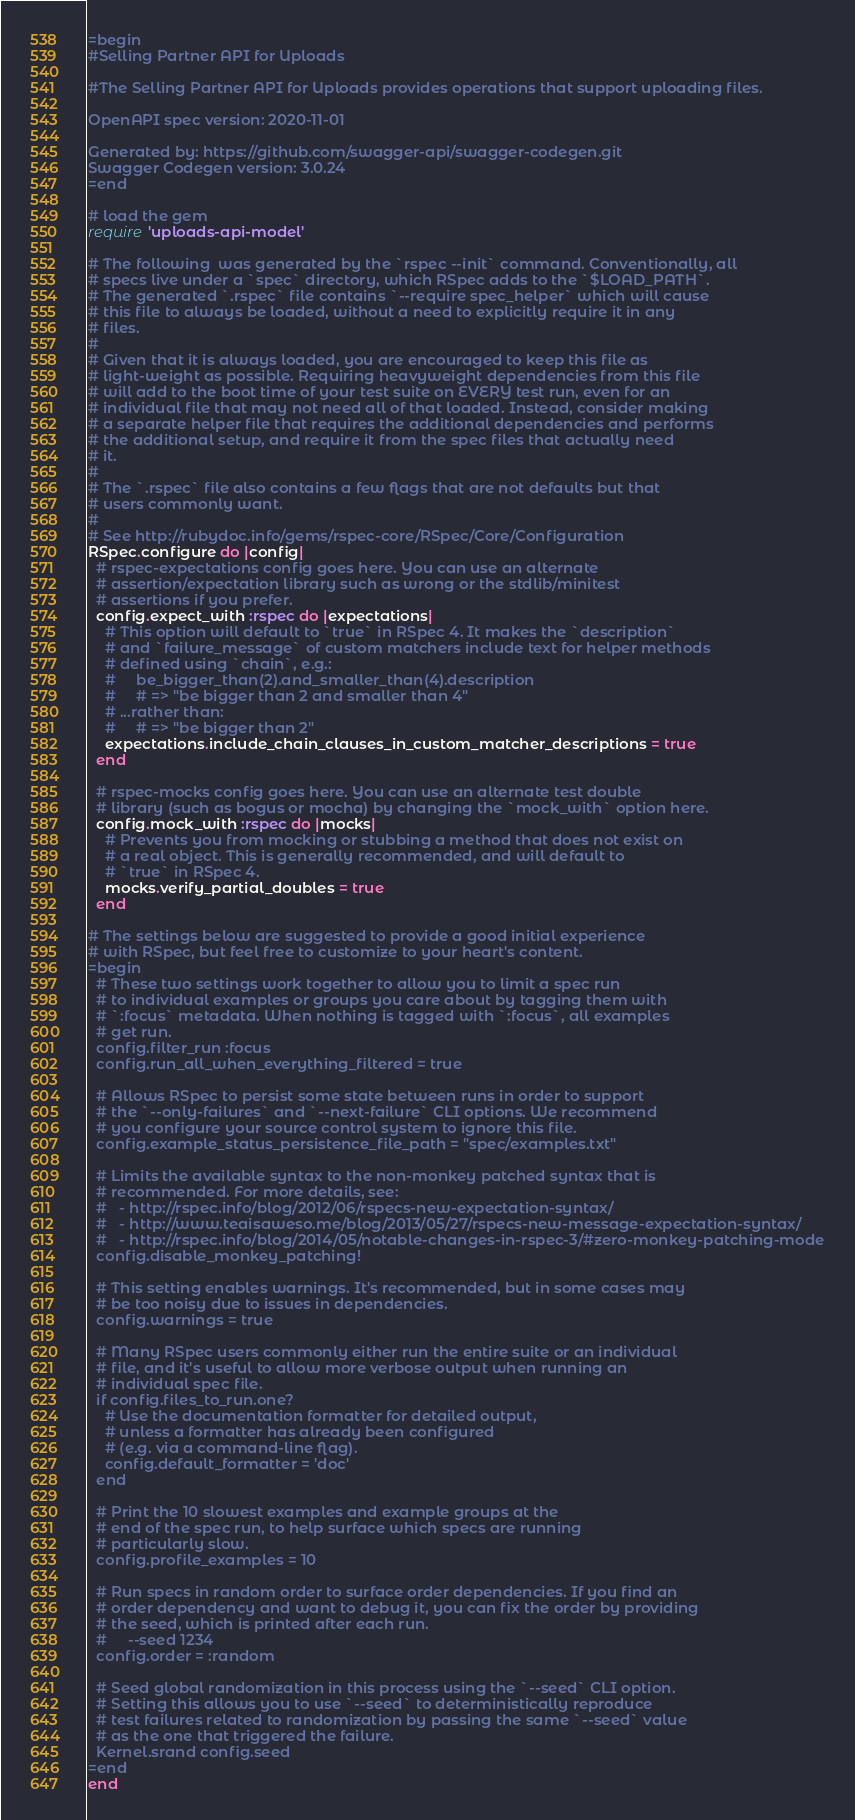<code> <loc_0><loc_0><loc_500><loc_500><_Ruby_>=begin
#Selling Partner API for Uploads

#The Selling Partner API for Uploads provides operations that support uploading files.

OpenAPI spec version: 2020-11-01

Generated by: https://github.com/swagger-api/swagger-codegen.git
Swagger Codegen version: 3.0.24
=end

# load the gem
require 'uploads-api-model'

# The following  was generated by the `rspec --init` command. Conventionally, all
# specs live under a `spec` directory, which RSpec adds to the `$LOAD_PATH`.
# The generated `.rspec` file contains `--require spec_helper` which will cause
# this file to always be loaded, without a need to explicitly require it in any
# files.
#
# Given that it is always loaded, you are encouraged to keep this file as
# light-weight as possible. Requiring heavyweight dependencies from this file
# will add to the boot time of your test suite on EVERY test run, even for an
# individual file that may not need all of that loaded. Instead, consider making
# a separate helper file that requires the additional dependencies and performs
# the additional setup, and require it from the spec files that actually need
# it.
#
# The `.rspec` file also contains a few flags that are not defaults but that
# users commonly want.
#
# See http://rubydoc.info/gems/rspec-core/RSpec/Core/Configuration
RSpec.configure do |config|
  # rspec-expectations config goes here. You can use an alternate
  # assertion/expectation library such as wrong or the stdlib/minitest
  # assertions if you prefer.
  config.expect_with :rspec do |expectations|
    # This option will default to `true` in RSpec 4. It makes the `description`
    # and `failure_message` of custom matchers include text for helper methods
    # defined using `chain`, e.g.:
    #     be_bigger_than(2).and_smaller_than(4).description
    #     # => "be bigger than 2 and smaller than 4"
    # ...rather than:
    #     # => "be bigger than 2"
    expectations.include_chain_clauses_in_custom_matcher_descriptions = true
  end

  # rspec-mocks config goes here. You can use an alternate test double
  # library (such as bogus or mocha) by changing the `mock_with` option here.
  config.mock_with :rspec do |mocks|
    # Prevents you from mocking or stubbing a method that does not exist on
    # a real object. This is generally recommended, and will default to
    # `true` in RSpec 4.
    mocks.verify_partial_doubles = true
  end

# The settings below are suggested to provide a good initial experience
# with RSpec, but feel free to customize to your heart's content.
=begin
  # These two settings work together to allow you to limit a spec run
  # to individual examples or groups you care about by tagging them with
  # `:focus` metadata. When nothing is tagged with `:focus`, all examples
  # get run.
  config.filter_run :focus
  config.run_all_when_everything_filtered = true

  # Allows RSpec to persist some state between runs in order to support
  # the `--only-failures` and `--next-failure` CLI options. We recommend
  # you configure your source control system to ignore this file.
  config.example_status_persistence_file_path = "spec/examples.txt"

  # Limits the available syntax to the non-monkey patched syntax that is
  # recommended. For more details, see:
  #   - http://rspec.info/blog/2012/06/rspecs-new-expectation-syntax/
  #   - http://www.teaisaweso.me/blog/2013/05/27/rspecs-new-message-expectation-syntax/
  #   - http://rspec.info/blog/2014/05/notable-changes-in-rspec-3/#zero-monkey-patching-mode
  config.disable_monkey_patching!

  # This setting enables warnings. It's recommended, but in some cases may
  # be too noisy due to issues in dependencies.
  config.warnings = true

  # Many RSpec users commonly either run the entire suite or an individual
  # file, and it's useful to allow more verbose output when running an
  # individual spec file.
  if config.files_to_run.one?
    # Use the documentation formatter for detailed output,
    # unless a formatter has already been configured
    # (e.g. via a command-line flag).
    config.default_formatter = 'doc'
  end

  # Print the 10 slowest examples and example groups at the
  # end of the spec run, to help surface which specs are running
  # particularly slow.
  config.profile_examples = 10

  # Run specs in random order to surface order dependencies. If you find an
  # order dependency and want to debug it, you can fix the order by providing
  # the seed, which is printed after each run.
  #     --seed 1234
  config.order = :random

  # Seed global randomization in this process using the `--seed` CLI option.
  # Setting this allows you to use `--seed` to deterministically reproduce
  # test failures related to randomization by passing the same `--seed` value
  # as the one that triggered the failure.
  Kernel.srand config.seed
=end
end
</code> 